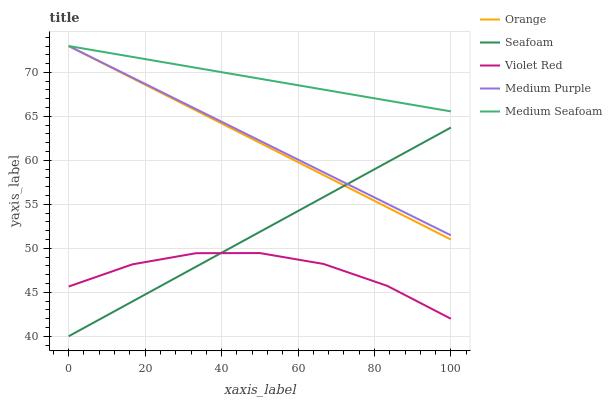Does Violet Red have the minimum area under the curve?
Answer yes or no. Yes. Does Medium Seafoam have the maximum area under the curve?
Answer yes or no. Yes. Does Medium Purple have the minimum area under the curve?
Answer yes or no. No. Does Medium Purple have the maximum area under the curve?
Answer yes or no. No. Is Seafoam the smoothest?
Answer yes or no. Yes. Is Violet Red the roughest?
Answer yes or no. Yes. Is Medium Purple the smoothest?
Answer yes or no. No. Is Medium Purple the roughest?
Answer yes or no. No. Does Seafoam have the lowest value?
Answer yes or no. Yes. Does Medium Purple have the lowest value?
Answer yes or no. No. Does Medium Seafoam have the highest value?
Answer yes or no. Yes. Does Violet Red have the highest value?
Answer yes or no. No. Is Violet Red less than Orange?
Answer yes or no. Yes. Is Medium Seafoam greater than Violet Red?
Answer yes or no. Yes. Does Orange intersect Medium Seafoam?
Answer yes or no. Yes. Is Orange less than Medium Seafoam?
Answer yes or no. No. Is Orange greater than Medium Seafoam?
Answer yes or no. No. Does Violet Red intersect Orange?
Answer yes or no. No. 